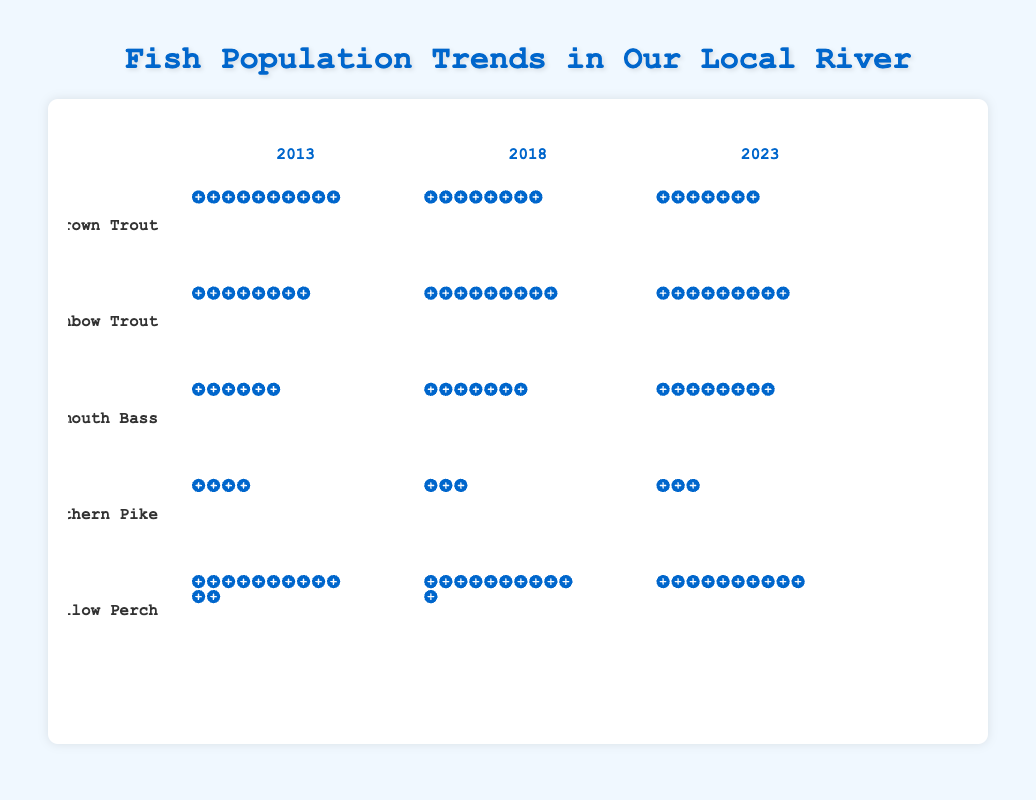How has the population of Brown Trout changed over the decade? The population of Brown Trout in 2013 was 1000, in 2018 it decreased to 850, and in 2023 it further decreased to 700. This shows a decreasing trend over the decade.
Answer: Decreased Which species showed an increase in population between 2013 and 2023? By observing the data, the Rainbow Trout increased from 800 to 950, and the Smallmouth Bass increased from 600 to 850.
Answer: Rainbow Trout, Smallmouth Bass By how much did the Yellow Perch population change from 2013 to 2018? The Yellow Perch population in 2013 was 1200, and in 2018 it was 1100. The change is 1200 - 1100 = 100.
Answer: 100 Between Northern Pike and Brown Trout, which species had a greater reduction in population from 2013 to 2023? The Brown Trout's population decreased from 1000 to 700, a reduction of 300. The Northern Pike's population decreased from 400 to 300, a reduction of 100. Brown Trout had a greater reduction.
Answer: Brown Trout What is the average population of Smallmouth Bass across the recorded years? The populations in 2013, 2018, and 2023 are 600, 750, and 850, respectively. The average is (600 + 750 + 850) / 3 = 733.33.
Answer: 733.33 Which year had the highest population for the most species? By examining the figure, 2023 had the highest population for Rainbow Trout and Smallmouth Bass, making it the year with the highest population for the most species (2 species).
Answer: 2023 How many species experienced a decline in population between 2018 and 2023? By observing the data from 2018 to 2023, Brown Trout decreased from 850 to 700, Northern Pike from 350 to 300, and Yellow Perch from 1100 to 1000. This makes 3 species.
Answer: 3 Which species had the least population change over the time period depicted? The Rainbow Trout population changed from 800 in 2013 to 950 in 2023, making it a change of 150. This is the smallest population change among the species shown.
Answer: Rainbow Trout How did the population of Northern Pike change between each recorded year? Between 2013 and 2018, the Northern Pike population decreased from 400 to 350 (a change of -50). Between 2018 and 2023, it decreased from 350 to 300 (a change of -50 again).
Answer: -50 each period 